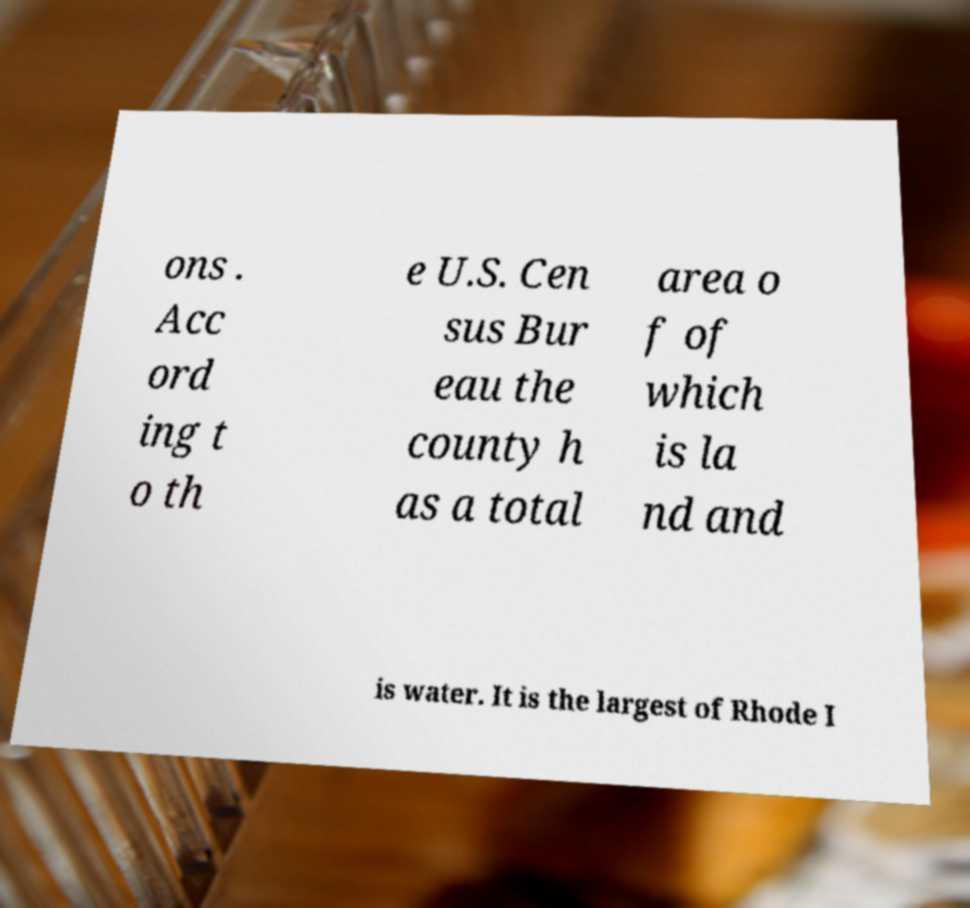Could you extract and type out the text from this image? ons . Acc ord ing t o th e U.S. Cen sus Bur eau the county h as a total area o f of which is la nd and is water. It is the largest of Rhode I 